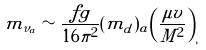<formula> <loc_0><loc_0><loc_500><loc_500>m _ { \nu _ { a } } \sim { \frac { f g } { 1 6 \pi ^ { 2 } } } ( m _ { d } ) _ { a } \left ( { \frac { \mu v } { M ^ { 2 } } } \right ) _ { , }</formula> 